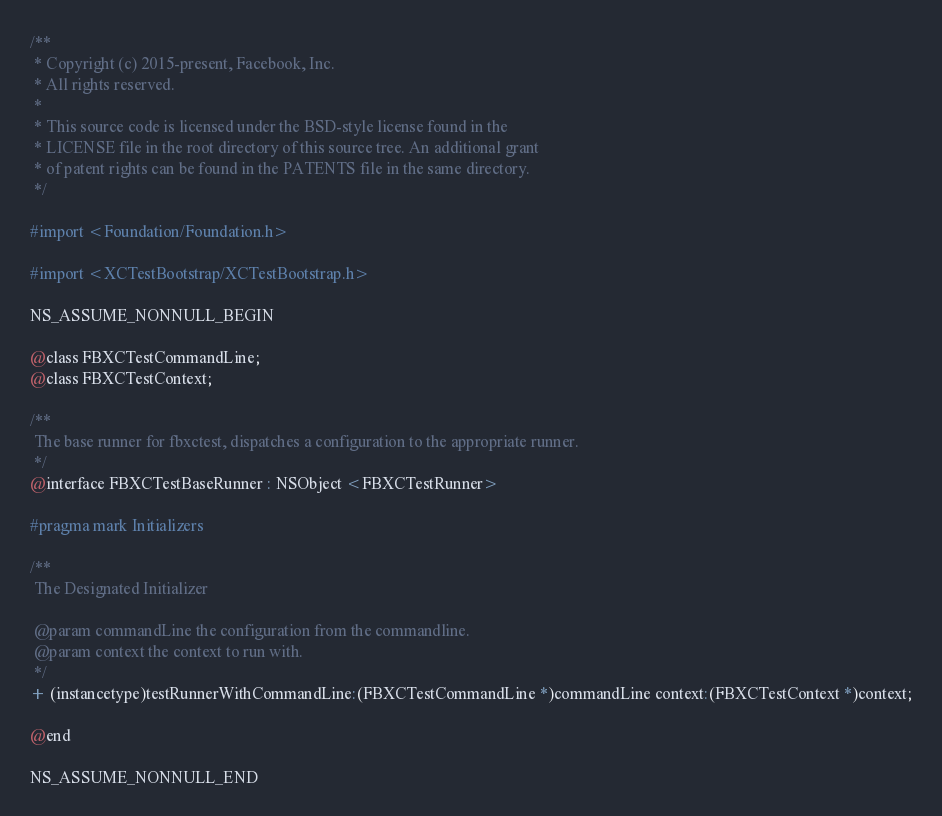Convert code to text. <code><loc_0><loc_0><loc_500><loc_500><_C_>/**
 * Copyright (c) 2015-present, Facebook, Inc.
 * All rights reserved.
 *
 * This source code is licensed under the BSD-style license found in the
 * LICENSE file in the root directory of this source tree. An additional grant
 * of patent rights can be found in the PATENTS file in the same directory.
 */

#import <Foundation/Foundation.h>

#import <XCTestBootstrap/XCTestBootstrap.h>

NS_ASSUME_NONNULL_BEGIN

@class FBXCTestCommandLine;
@class FBXCTestContext;

/**
 The base runner for fbxctest, dispatches a configuration to the appropriate runner.
 */
@interface FBXCTestBaseRunner : NSObject <FBXCTestRunner>

#pragma mark Initializers

/**
 The Designated Initializer

 @param commandLine the configuration from the commandline.
 @param context the context to run with.
 */
+ (instancetype)testRunnerWithCommandLine:(FBXCTestCommandLine *)commandLine context:(FBXCTestContext *)context;

@end

NS_ASSUME_NONNULL_END
</code> 